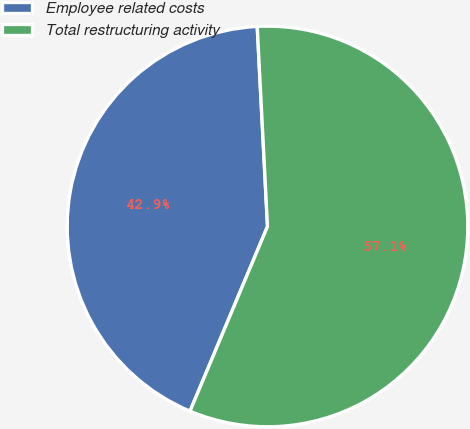Convert chart to OTSL. <chart><loc_0><loc_0><loc_500><loc_500><pie_chart><fcel>Employee related costs<fcel>Total restructuring activity<nl><fcel>42.86%<fcel>57.14%<nl></chart> 